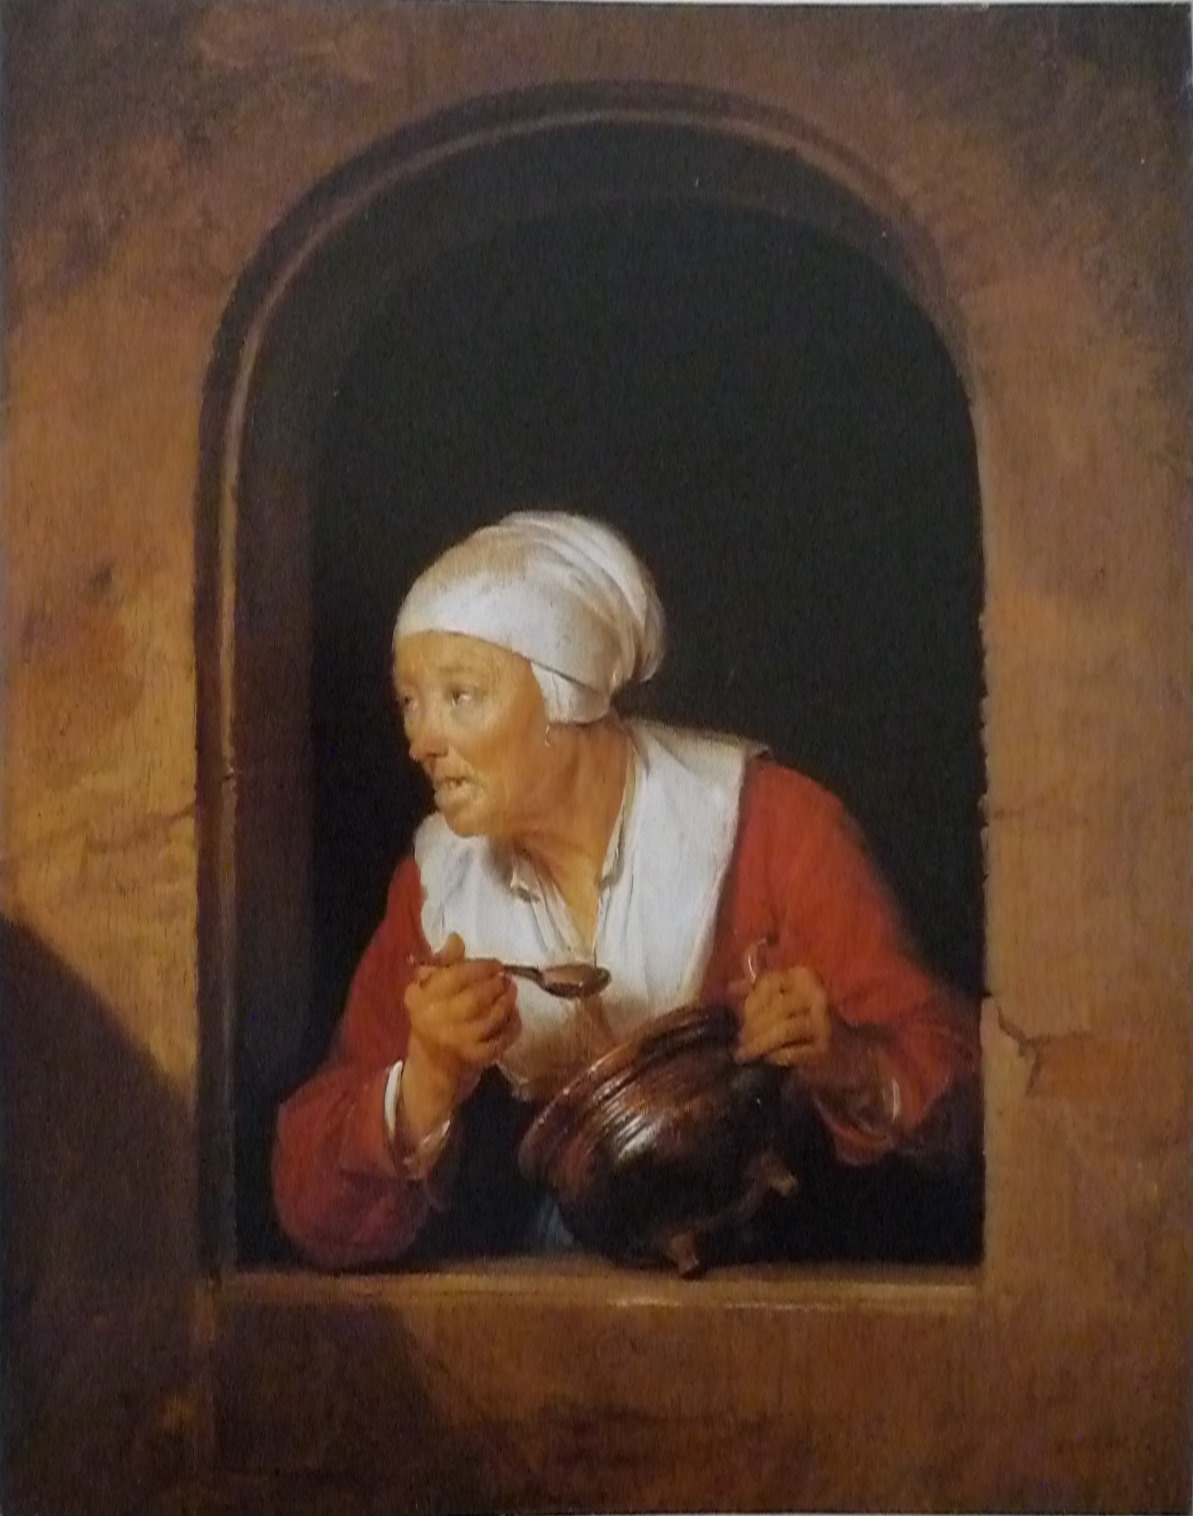What does her attire tell us about her social status or the period in which she lived? Her attire, consisting of a simple but vivid red blouse and a utilitarian white headscarf, suggests a humble position in society, perhaps that of a commoner or a working-class individual. The style of clothing, along with the earthenware jug, might place her in a historical context where such vessels were everyday items, possibly in a European setting several centuries ago. 